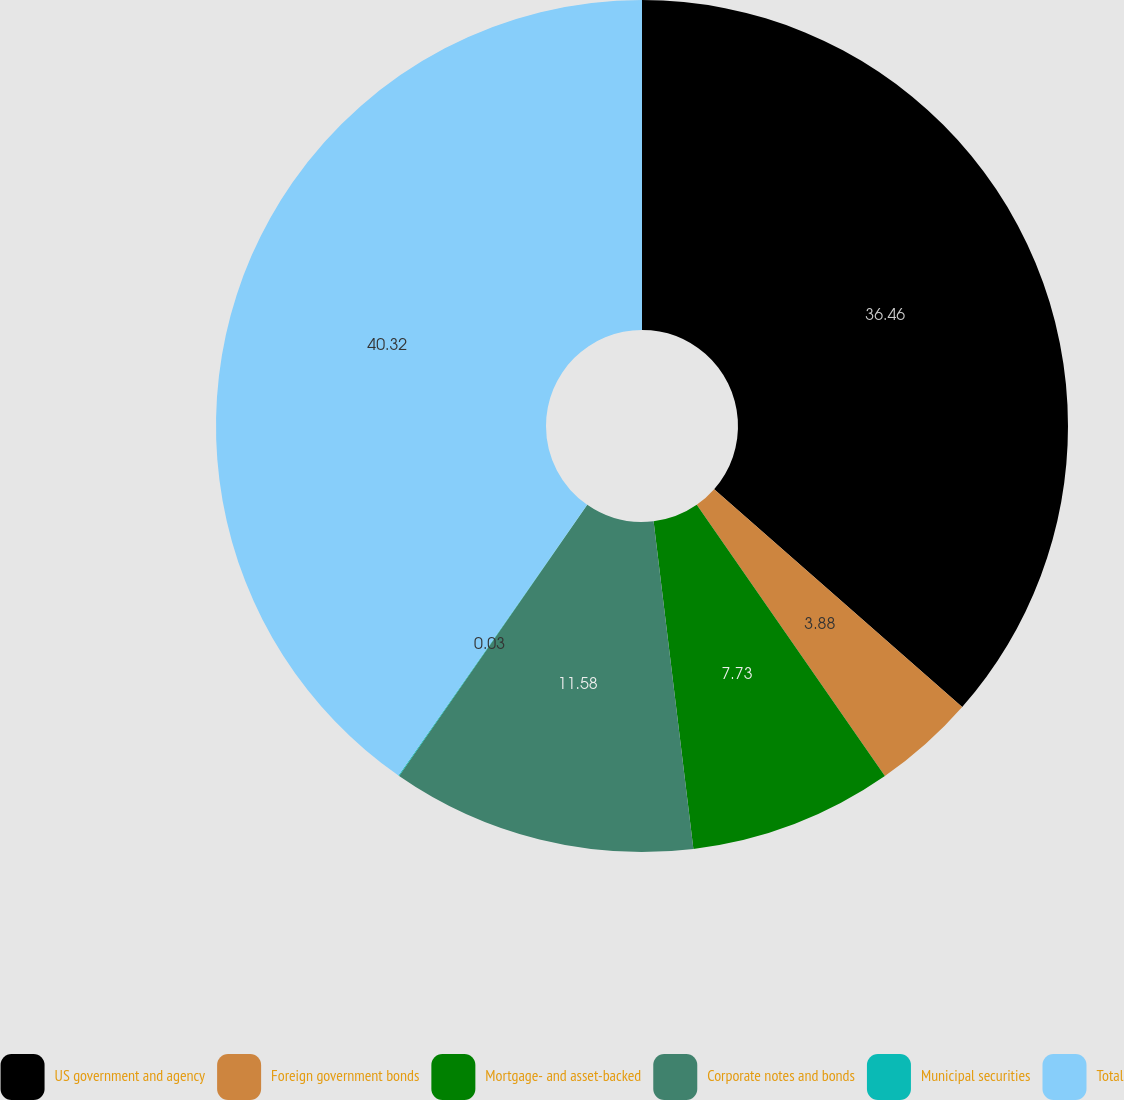Convert chart to OTSL. <chart><loc_0><loc_0><loc_500><loc_500><pie_chart><fcel>US government and agency<fcel>Foreign government bonds<fcel>Mortgage- and asset-backed<fcel>Corporate notes and bonds<fcel>Municipal securities<fcel>Total<nl><fcel>36.46%<fcel>3.88%<fcel>7.73%<fcel>11.58%<fcel>0.03%<fcel>40.31%<nl></chart> 